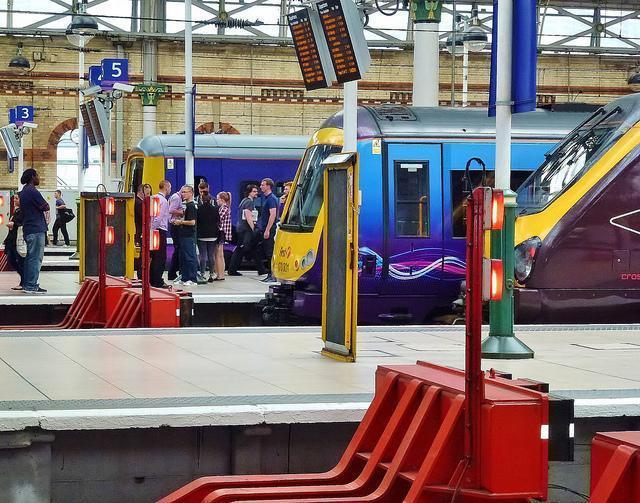How many trains are in the photo?
Give a very brief answer. 3. How many people are in the picture?
Give a very brief answer. 2. 